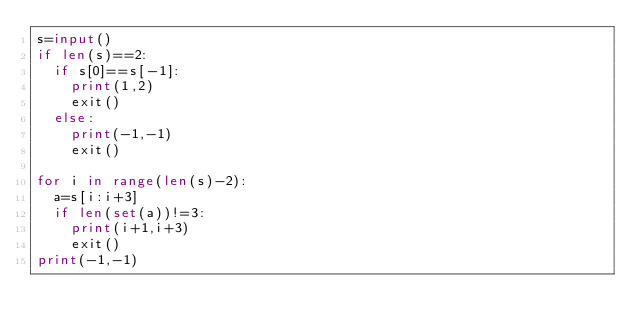Convert code to text. <code><loc_0><loc_0><loc_500><loc_500><_Python_>s=input()
if len(s)==2:
  if s[0]==s[-1]:
    print(1,2)
    exit()
  else:
    print(-1,-1)
    exit()
    
for i in range(len(s)-2):
  a=s[i:i+3]
  if len(set(a))!=3:
    print(i+1,i+3)
    exit()
print(-1,-1)
</code> 